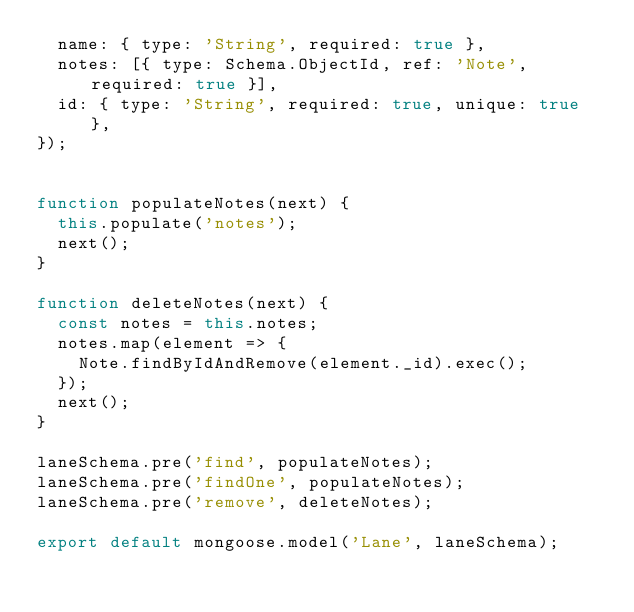<code> <loc_0><loc_0><loc_500><loc_500><_JavaScript_>  name: { type: 'String', required: true },
  notes: [{ type: Schema.ObjectId, ref: 'Note', required: true }],
  id: { type: 'String', required: true, unique: true },
});


function populateNotes(next) {
  this.populate('notes');
  next();
}

function deleteNotes(next) {
  const notes = this.notes;
  notes.map(element => {
    Note.findByIdAndRemove(element._id).exec();
  });
  next();
}

laneSchema.pre('find', populateNotes);
laneSchema.pre('findOne', populateNotes);
laneSchema.pre('remove', deleteNotes);

export default mongoose.model('Lane', laneSchema);
</code> 